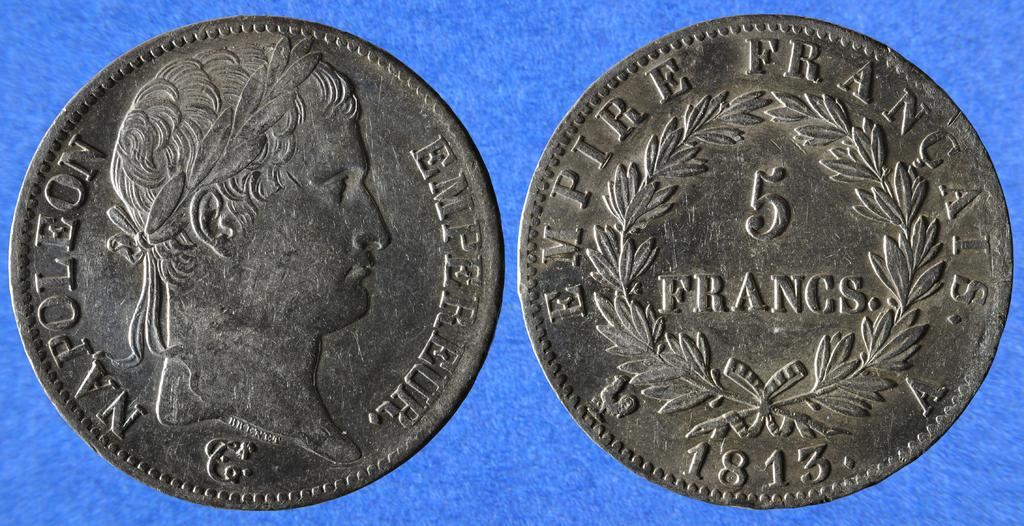<image>
Share a concise interpretation of the image provided. Front and back of a coin shwoing Napoleon on it. 